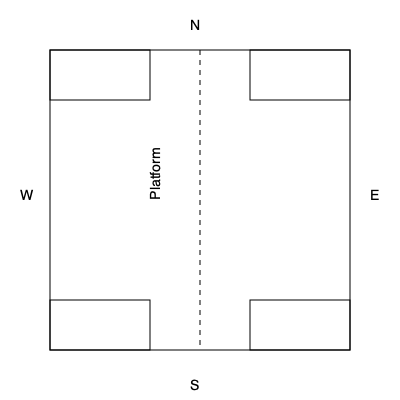Based on the historical blueprint of Keenesburg's railway station, which direction does the main platform face? To determine the orientation of the main platform in this historical railway station blueprint:

1. Observe the compass directions marked on the diagram (N, E, S, W).
2. Locate the main platform, which is typically the longest continuous structure in a railway station blueprint.
3. In this diagram, the platform is represented by the dashed line running vertically through the center of the blueprint.
4. The platform extends from the North (N) to the South (S) of the diagram.
5. In railway station design, platforms are typically described by the direction passengers face when standing on them and looking towards the tracks.
6. Given that the platform runs North-South, passengers would face either East or West when standing on it.
7. By convention, the main platform usually faces the town or main approach to the station.
8. In this case, the left side of the diagram (marked W for West) would likely represent the town side or main approach.

Therefore, the main platform faces West, as passengers would look West when standing on the platform facing the town or main approach to the station.
Answer: West 